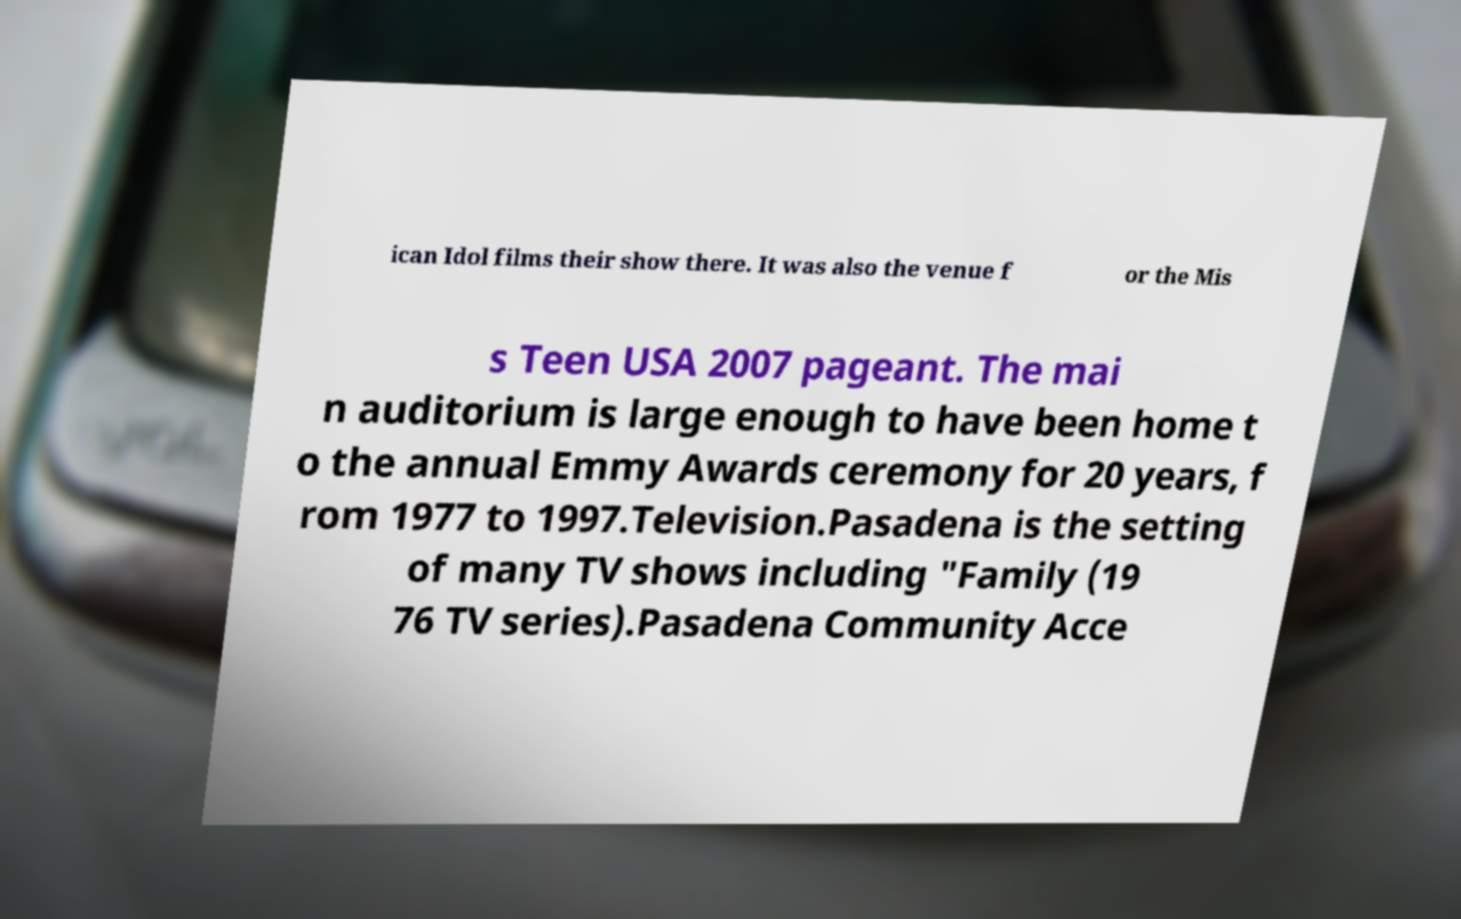Please identify and transcribe the text found in this image. ican Idol films their show there. It was also the venue f or the Mis s Teen USA 2007 pageant. The mai n auditorium is large enough to have been home t o the annual Emmy Awards ceremony for 20 years, f rom 1977 to 1997.Television.Pasadena is the setting of many TV shows including "Family (19 76 TV series).Pasadena Community Acce 